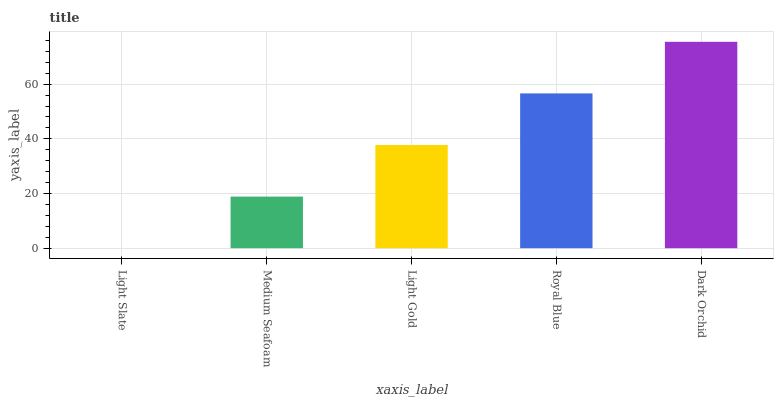Is Dark Orchid the maximum?
Answer yes or no. Yes. Is Medium Seafoam the minimum?
Answer yes or no. No. Is Medium Seafoam the maximum?
Answer yes or no. No. Is Medium Seafoam greater than Light Slate?
Answer yes or no. Yes. Is Light Slate less than Medium Seafoam?
Answer yes or no. Yes. Is Light Slate greater than Medium Seafoam?
Answer yes or no. No. Is Medium Seafoam less than Light Slate?
Answer yes or no. No. Is Light Gold the high median?
Answer yes or no. Yes. Is Light Gold the low median?
Answer yes or no. Yes. Is Royal Blue the high median?
Answer yes or no. No. Is Royal Blue the low median?
Answer yes or no. No. 